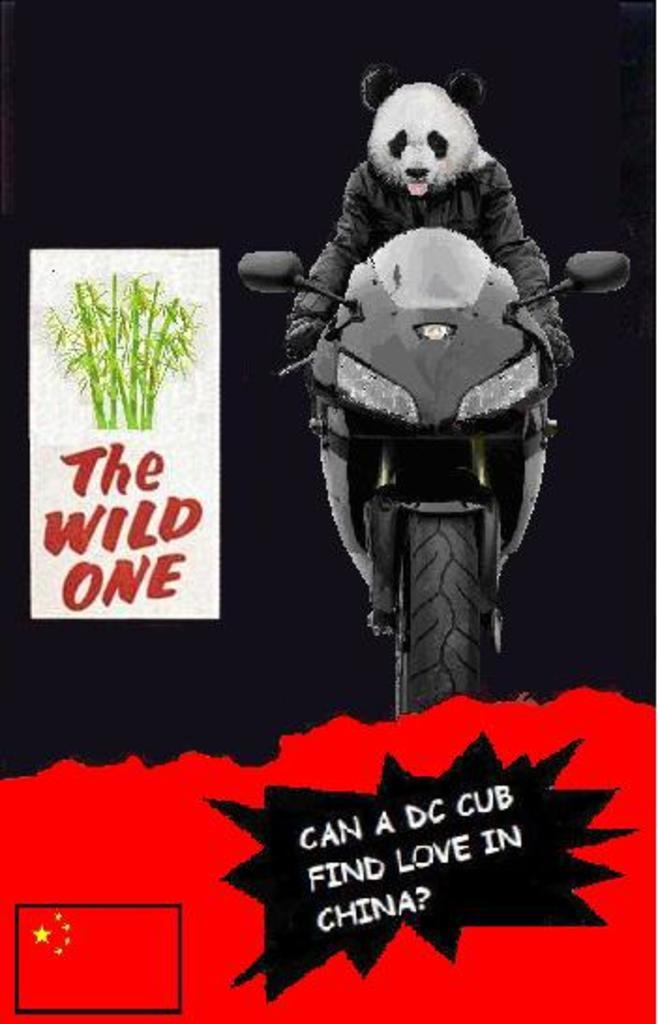What is present on the poster in the image? There is a poster in the image, and it contains text. What image is depicted on the poster? There is a motorcycle depicted on the poster. Where is the nearest market to the location of the poster in the image? The provided facts do not mention any information about a market or its location, so it cannot be determined from the image. What type of print is used for the text on the poster? The provided facts do not mention any information about the type of print used for the text on the poster, so it cannot be determined from the image. 